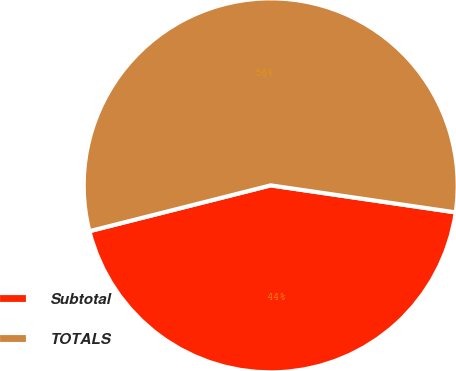<chart> <loc_0><loc_0><loc_500><loc_500><pie_chart><fcel>Subtotal<fcel>TOTALS<nl><fcel>43.75%<fcel>56.25%<nl></chart> 